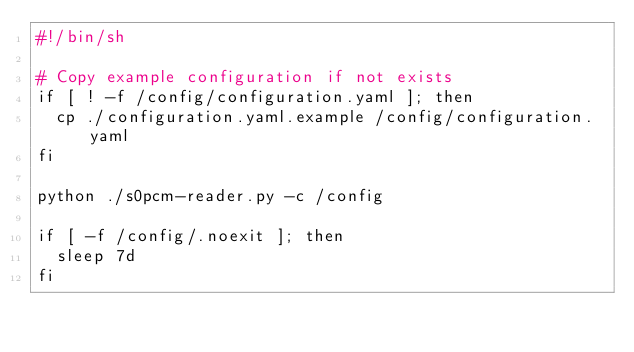Convert code to text. <code><loc_0><loc_0><loc_500><loc_500><_Bash_>#!/bin/sh

# Copy example configuration if not exists
if [ ! -f /config/configuration.yaml ]; then
  cp ./configuration.yaml.example /config/configuration.yaml
fi

python ./s0pcm-reader.py -c /config

if [ -f /config/.noexit ]; then
  sleep 7d
fi
</code> 